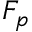<formula> <loc_0><loc_0><loc_500><loc_500>F _ { p }</formula> 